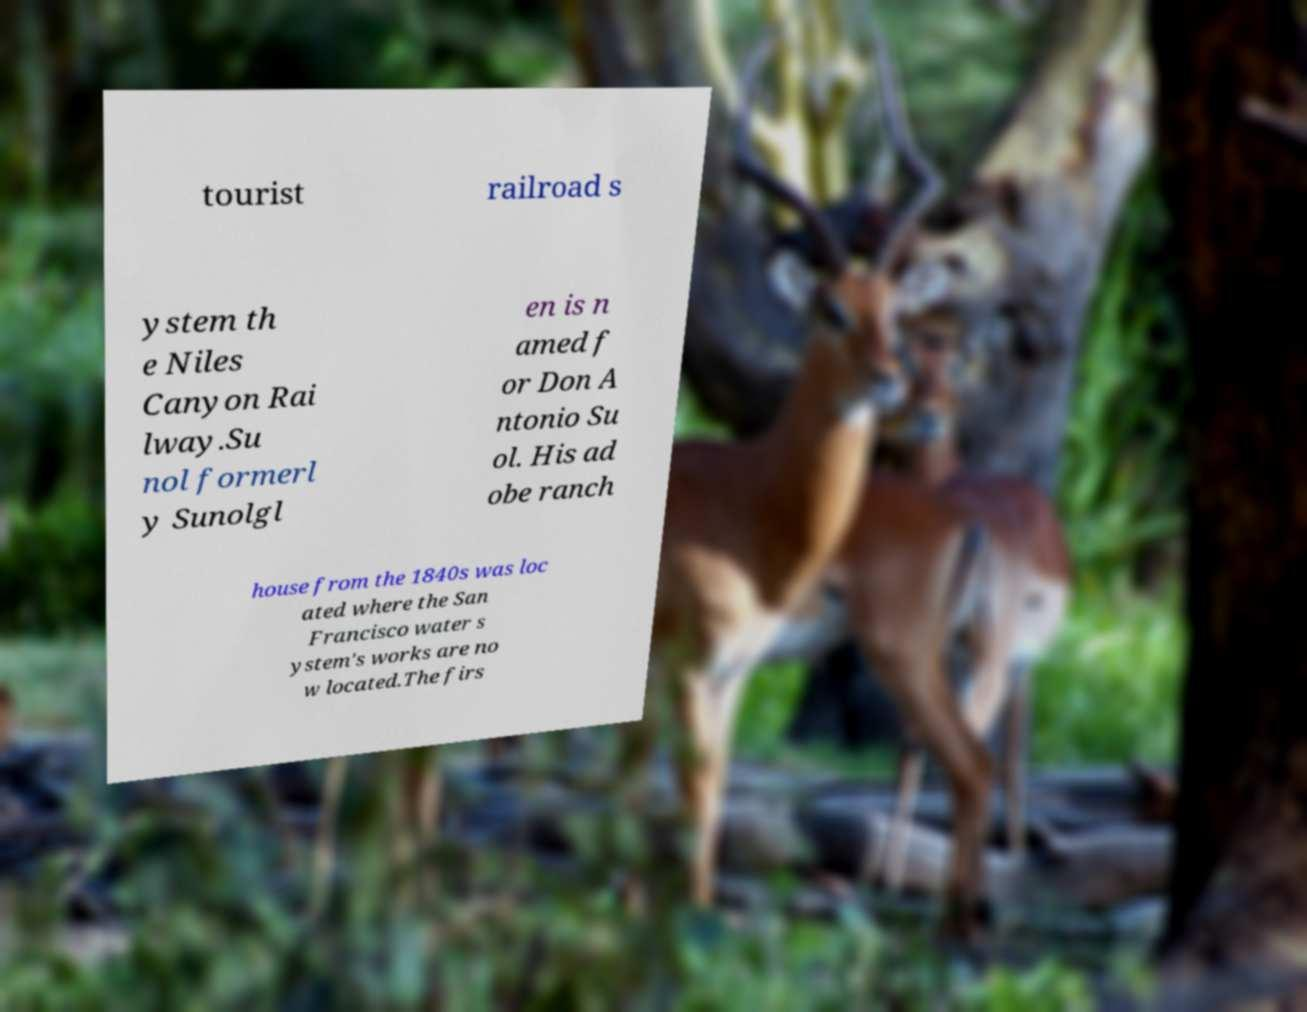What messages or text are displayed in this image? I need them in a readable, typed format. tourist railroad s ystem th e Niles Canyon Rai lway.Su nol formerl y Sunolgl en is n amed f or Don A ntonio Su ol. His ad obe ranch house from the 1840s was loc ated where the San Francisco water s ystem's works are no w located.The firs 